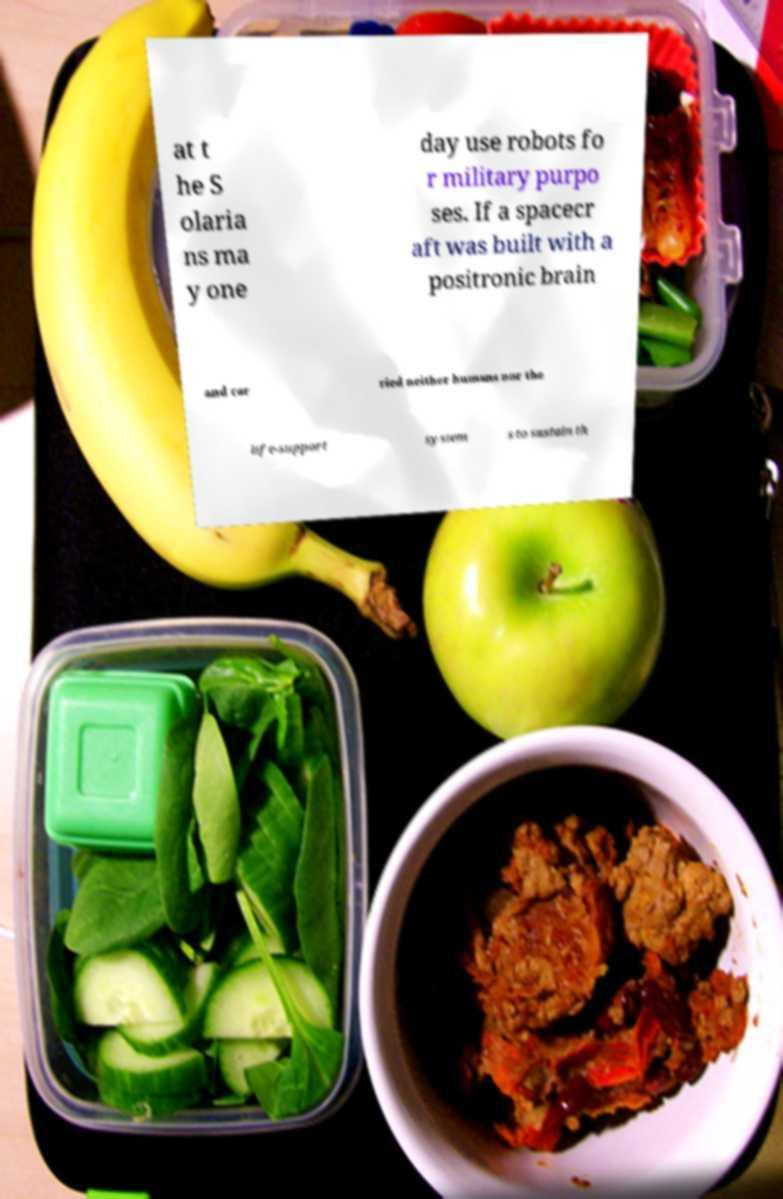There's text embedded in this image that I need extracted. Can you transcribe it verbatim? at t he S olaria ns ma y one day use robots fo r military purpo ses. If a spacecr aft was built with a positronic brain and car ried neither humans nor the life-support system s to sustain th 